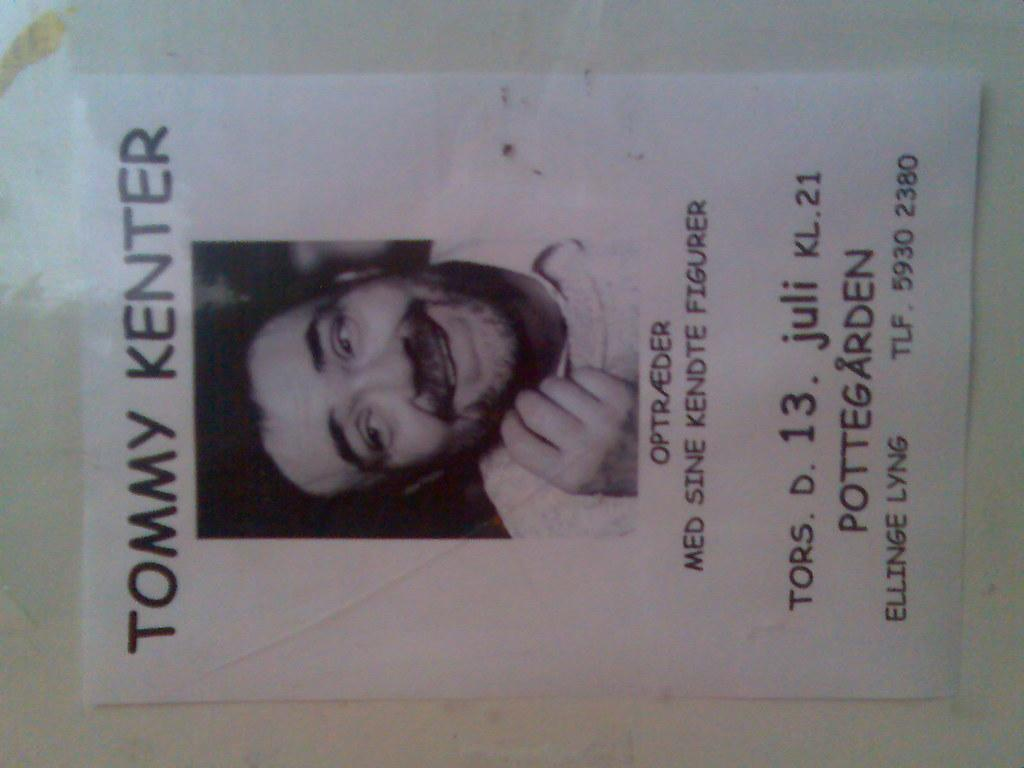<image>
Give a short and clear explanation of the subsequent image. A poster for Tommy Kenter hangs from a white wall 